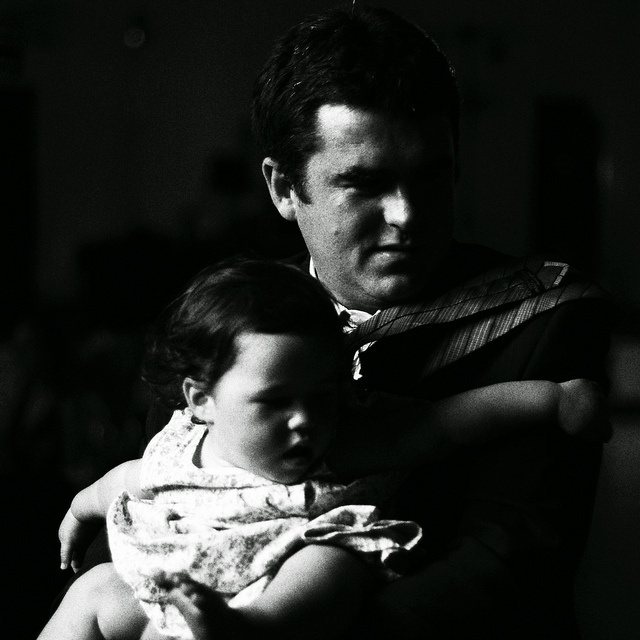Describe the objects in this image and their specific colors. I can see people in black, gray, darkgray, and lightgray tones, people in black, lightgray, gray, and darkgray tones, and tie in black, gray, darkgray, and white tones in this image. 